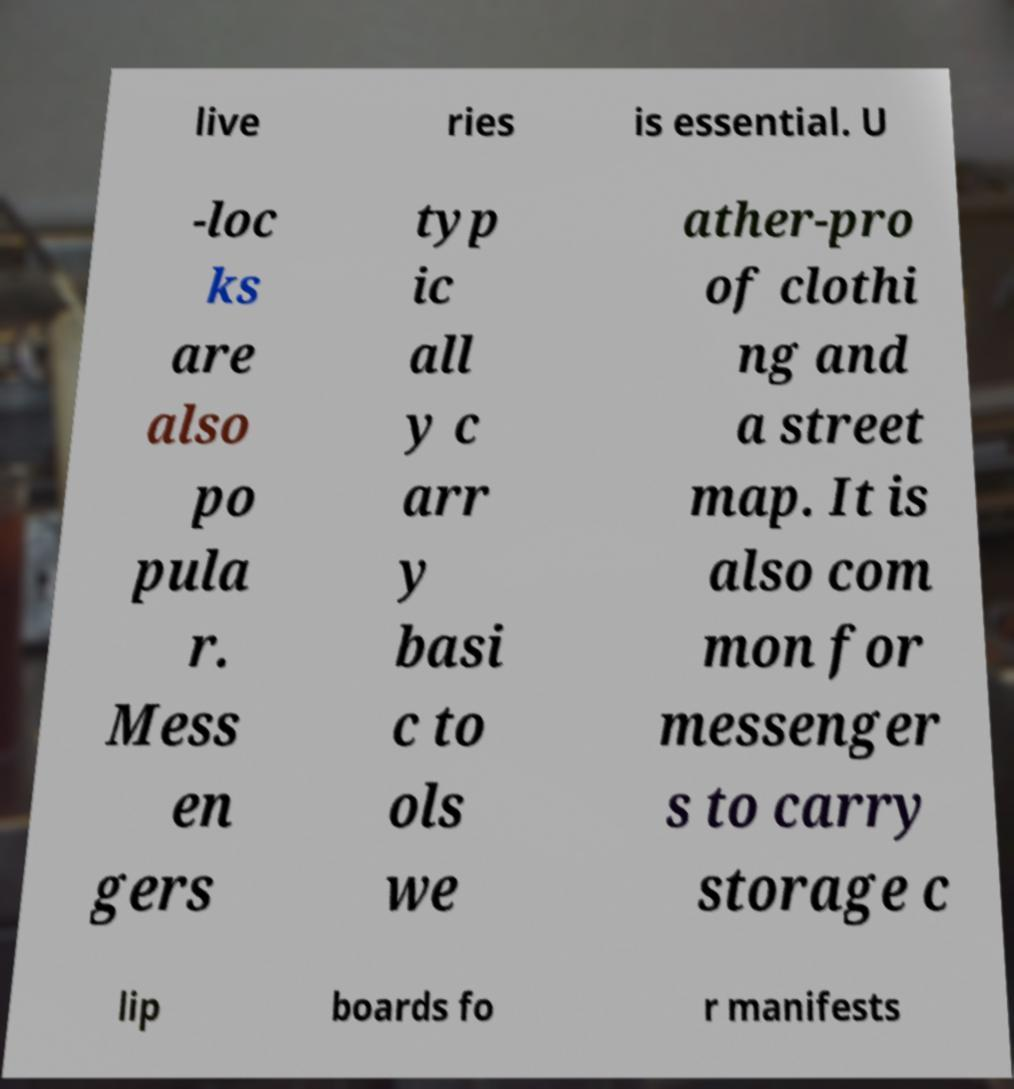I need the written content from this picture converted into text. Can you do that? live ries is essential. U -loc ks are also po pula r. Mess en gers typ ic all y c arr y basi c to ols we ather-pro of clothi ng and a street map. It is also com mon for messenger s to carry storage c lip boards fo r manifests 